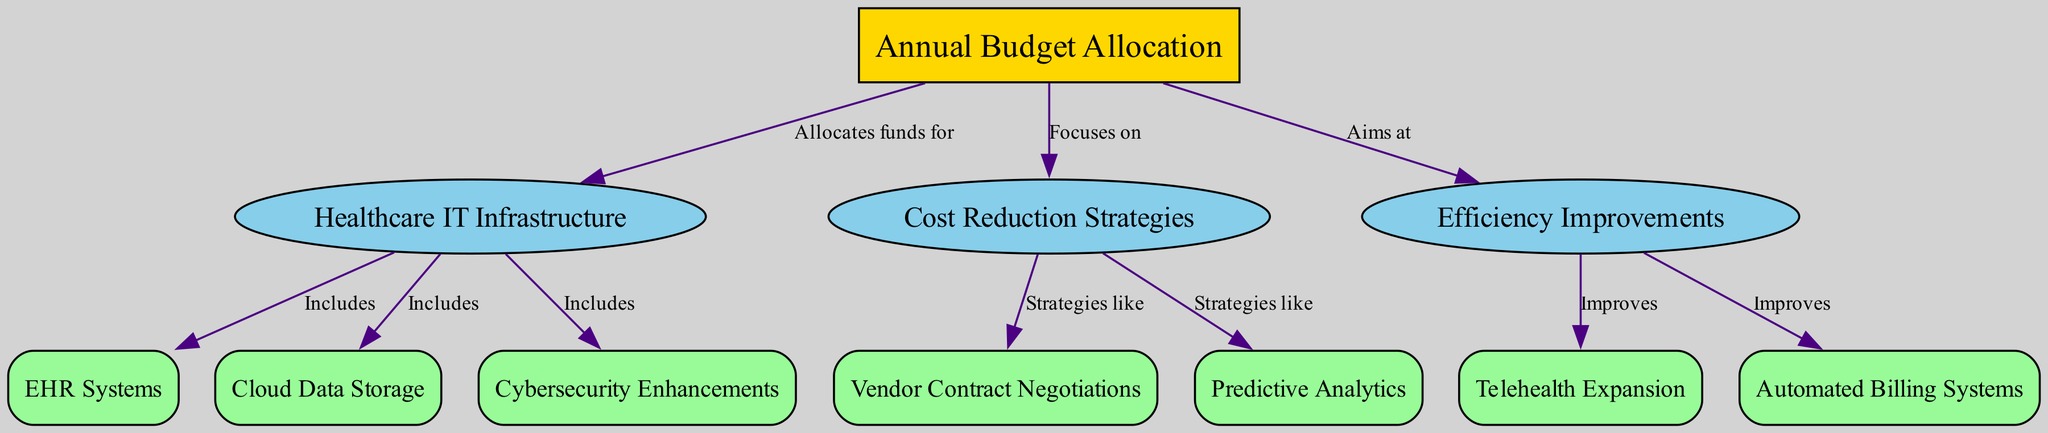What is the main focus of the Annual Budget Allocation? The diagram indicates that the Annual Budget Allocation focuses on both Cost Reduction Strategies and Efficiency Improvements. This information is based on the directed connection from the root node to those two categories, as both are labeled with the phrase "Focuses on."
Answer: Cost Reduction Strategies and Efficiency Improvements How many subcategories are under Healthcare IT Infrastructure? By counting the connections from the Healthcare IT Infrastructure node, we can see that there are three direct connections leading to EHR Systems, Cloud Data Storage, and Cybersecurity Enhancements. Thus, there are three subcategories in total.
Answer: 3 What does the Cost Reduction Strategies category include? The diagram shows that the Cost Reduction Strategies category includes Vendor Contract Negotiations and Predictive Analytics, as indicated by the connections labeled "Strategies like." Therefore, the total components can be easily identified under this category.
Answer: Vendor Contract Negotiations and Predictive Analytics Which aspect does Efficiency Improvements aim to enhance? According to the diagram, Efficiency Improvements aims to enhance Telehealth Expansion and Automated Billing Systems, indicated by the directed edges showing clear relationships labeled "Improves." Therefore, we understand the two aspects targeted for improvements.
Answer: Telehealth Expansion and Automated Billing Systems What is the relationship between Annual Budget Allocation and Healthcare IT Infrastructure? The relationship is defined by the phrase "Allocates funds for," which signifies that the Annual Budget Allocation directly supports the Healthcare IT Infrastructure category. This connection showcases the primary aim of the allocations.
Answer: Allocates funds for How many direct connections does the Annual Budget Allocation node have? The Annual Budget Allocation node has three direct connections; one to Healthcare IT Infrastructure, one to Cost Reduction Strategies, and another to Efficiency Improvements. By counting these edges, we derive the overall connections.
Answer: 3 What is included in the subcategory under Healthcare IT Infrastructure that focuses on data handling? The subcategory focused on data handling in Healthcare IT Infrastructure is Cloud Data Storage, as it is labeled as a component of that main category. Evidence of inclusion is shown with the directed edge indicating "Includes."
Answer: Cloud Data Storage What are two strategies associated with Cost Reduction? The strategies associated with Cost Reduction identified in the diagram are Vendor Contract Negotiations and Predictive Analytics. Each of these strategies is linked directly to the Cost Reduction Strategies category, cementing their role within this framework.
Answer: Vendor Contract Negotiations and Predictive Analytics 